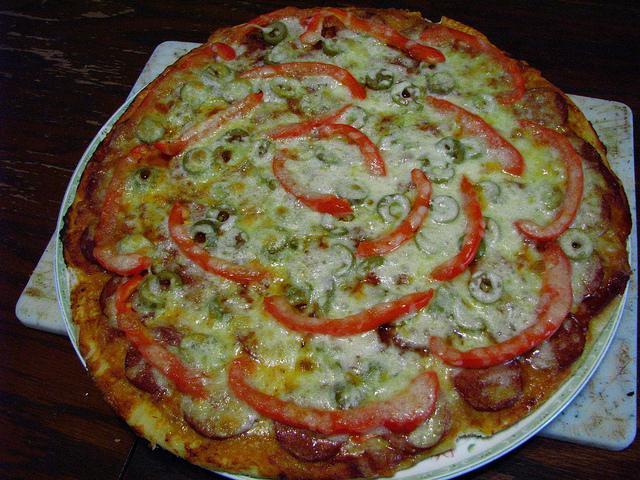How many different kinds of pizza are integrated into this one pizza?
Give a very brief answer. 1. 